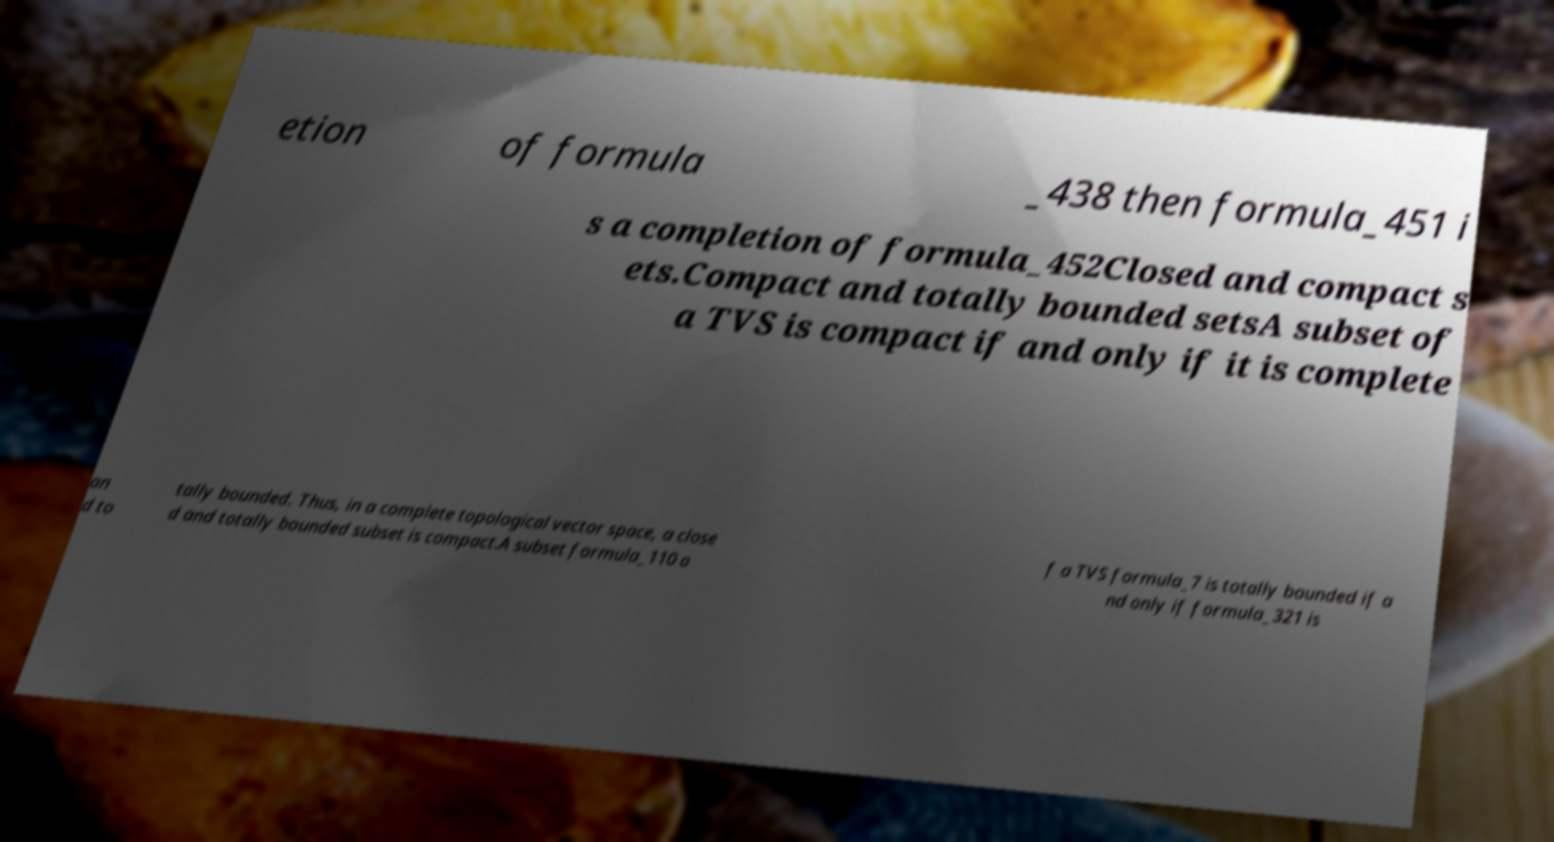I need the written content from this picture converted into text. Can you do that? etion of formula _438 then formula_451 i s a completion of formula_452Closed and compact s ets.Compact and totally bounded setsA subset of a TVS is compact if and only if it is complete an d to tally bounded. Thus, in a complete topological vector space, a close d and totally bounded subset is compact.A subset formula_110 o f a TVS formula_7 is totally bounded if a nd only if formula_321 is 